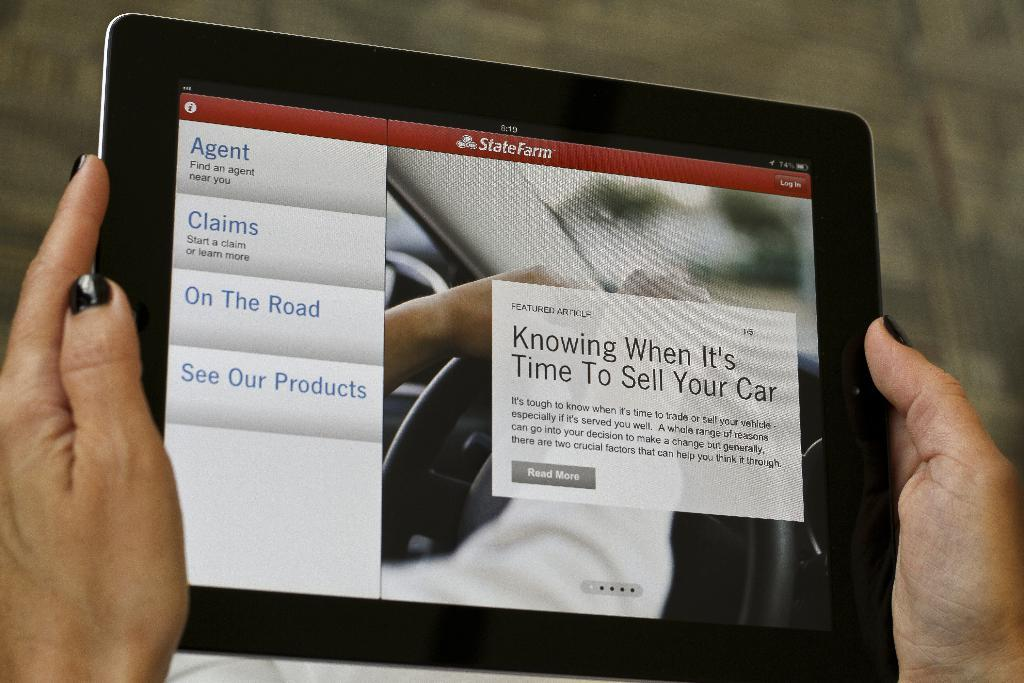What is the main subject of the image? There is a person in the image. What is the person holding in their hands? The person is holding an iPod in their hands. What type of goldfish is swimming in the background of the image? There is no goldfish present in the image; it only features a person holding an iPod. 